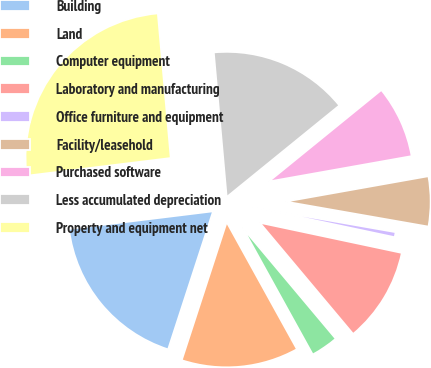<chart> <loc_0><loc_0><loc_500><loc_500><pie_chart><fcel>Building<fcel>Land<fcel>Computer equipment<fcel>Laboratory and manufacturing<fcel>Office furniture and equipment<fcel>Facility/leasehold<fcel>Purchased software<fcel>Less accumulated depreciation<fcel>Property and equipment net<nl><fcel>18.04%<fcel>13.05%<fcel>3.07%<fcel>10.56%<fcel>0.57%<fcel>5.56%<fcel>8.06%<fcel>15.55%<fcel>25.53%<nl></chart> 